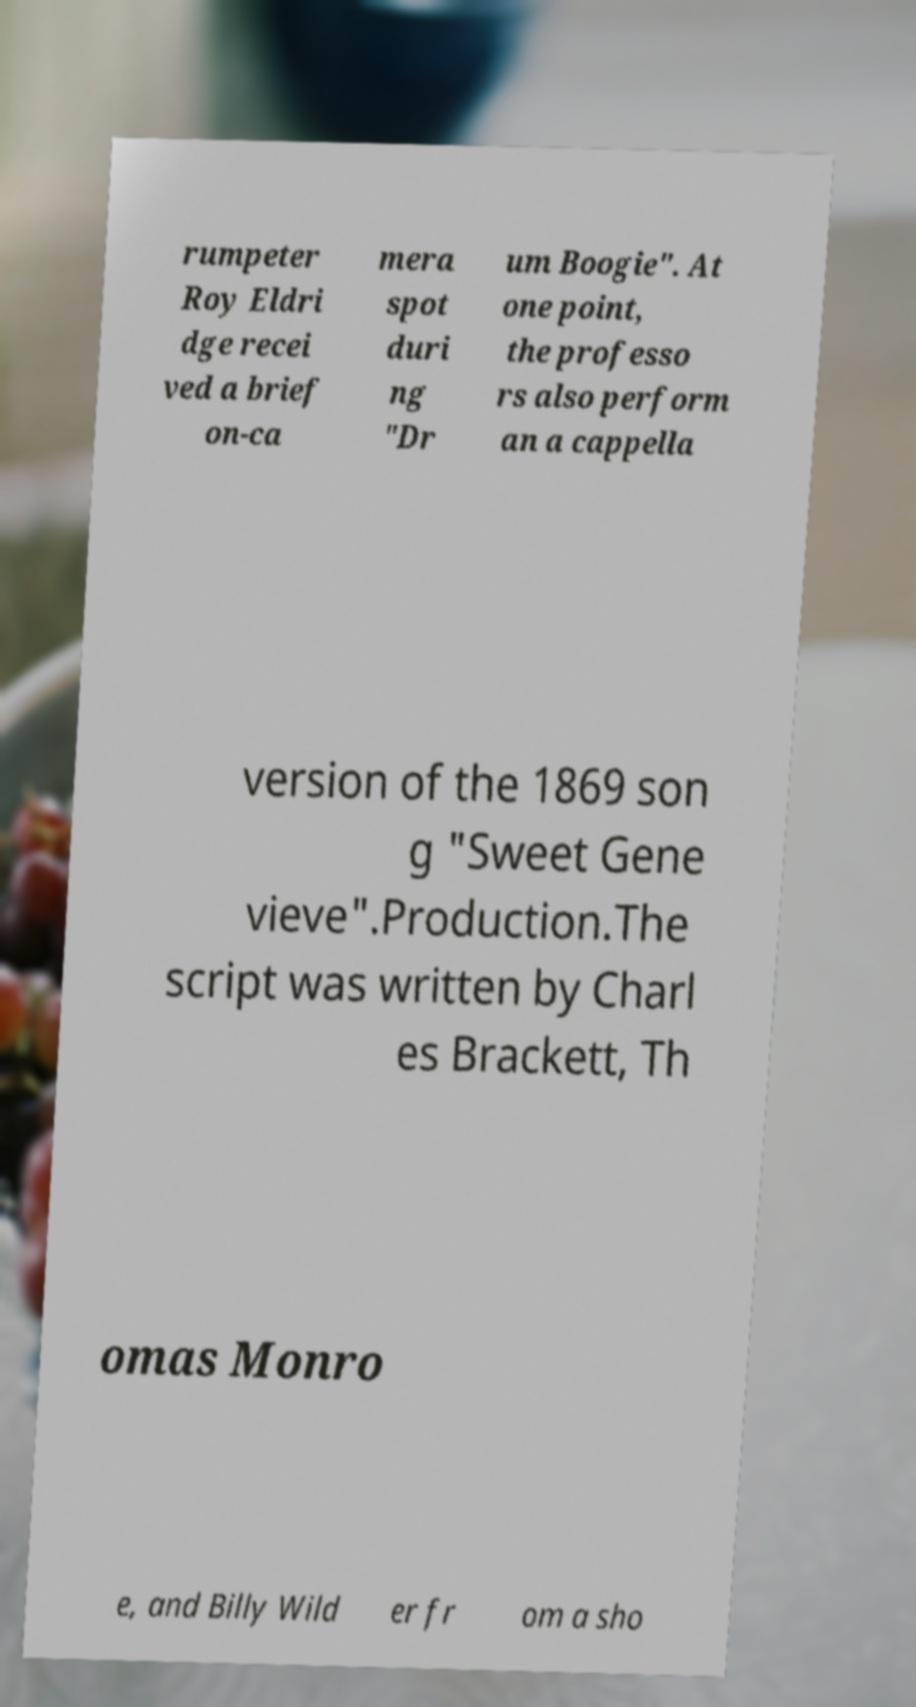What messages or text are displayed in this image? I need them in a readable, typed format. rumpeter Roy Eldri dge recei ved a brief on-ca mera spot duri ng "Dr um Boogie". At one point, the professo rs also perform an a cappella version of the 1869 son g "Sweet Gene vieve".Production.The script was written by Charl es Brackett, Th omas Monro e, and Billy Wild er fr om a sho 